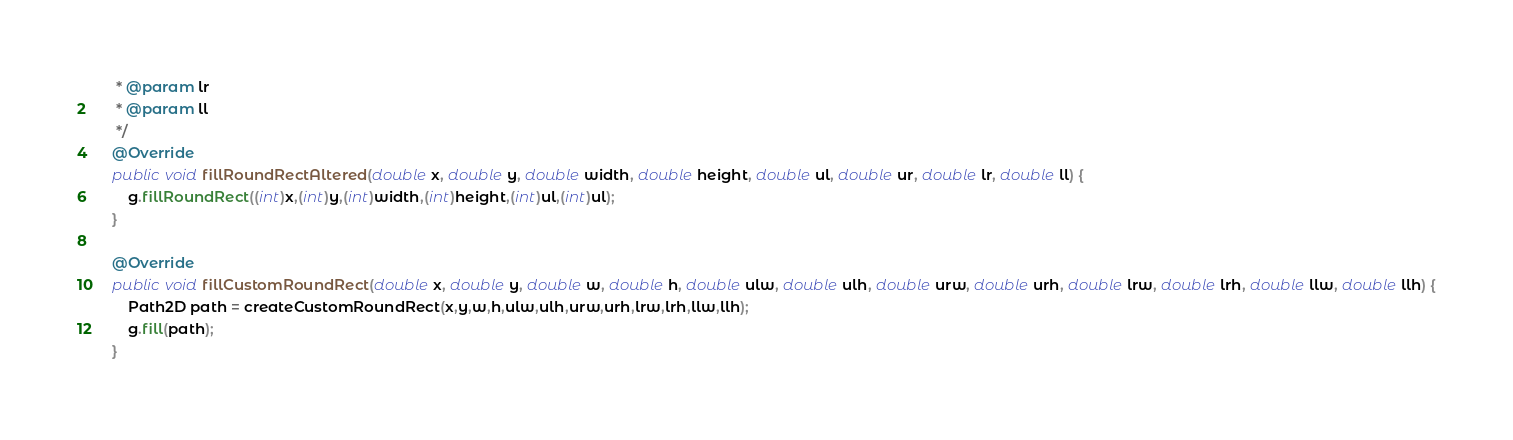Convert code to text. <code><loc_0><loc_0><loc_500><loc_500><_Java_>     * @param lr
     * @param ll
     */
    @Override
    public void fillRoundRectAltered(double x, double y, double width, double height, double ul, double ur, double lr, double ll) {
        g.fillRoundRect((int)x,(int)y,(int)width,(int)height,(int)ul,(int)ul);
    }

    @Override
    public void fillCustomRoundRect(double x, double y, double w, double h, double ulw, double ulh, double urw, double urh, double lrw, double lrh, double llw, double llh) {
        Path2D path = createCustomRoundRect(x,y,w,h,ulw,ulh,urw,urh,lrw,lrh,llw,llh);
        g.fill(path);
    }
</code> 